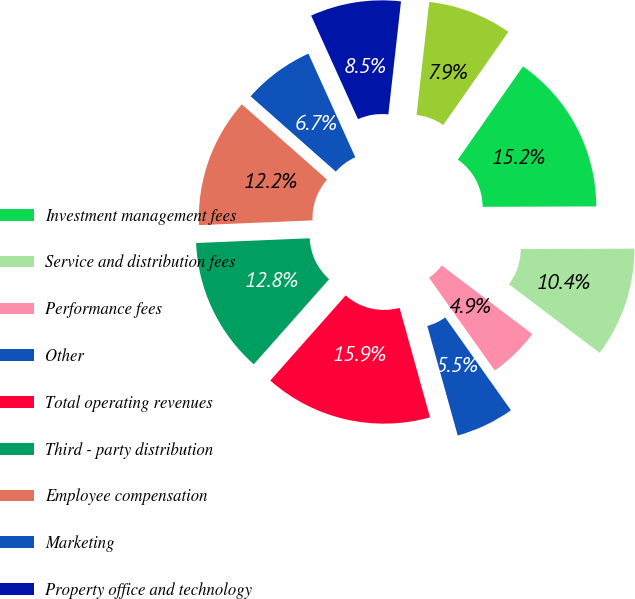<chart> <loc_0><loc_0><loc_500><loc_500><pie_chart><fcel>Investment management fees<fcel>Service and distribution fees<fcel>Performance fees<fcel>Other<fcel>Total operating revenues<fcel>Third - party distribution<fcel>Employee compensation<fcel>Marketing<fcel>Property office and technology<fcel>General and administrative<nl><fcel>15.24%<fcel>10.37%<fcel>4.88%<fcel>5.49%<fcel>15.85%<fcel>12.8%<fcel>12.19%<fcel>6.71%<fcel>8.54%<fcel>7.93%<nl></chart> 